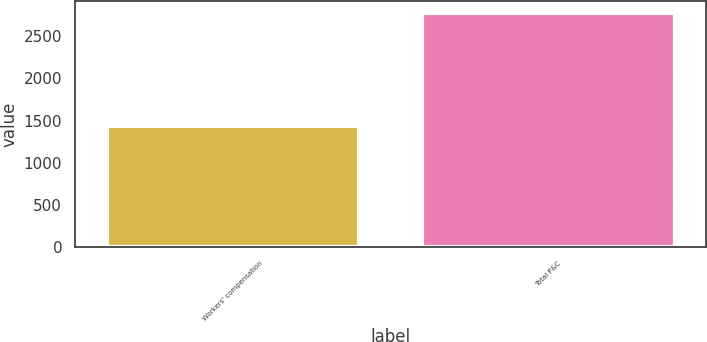Convert chart. <chart><loc_0><loc_0><loc_500><loc_500><bar_chart><fcel>Workers' compensation<fcel>Total P&C<nl><fcel>1431<fcel>2776<nl></chart> 